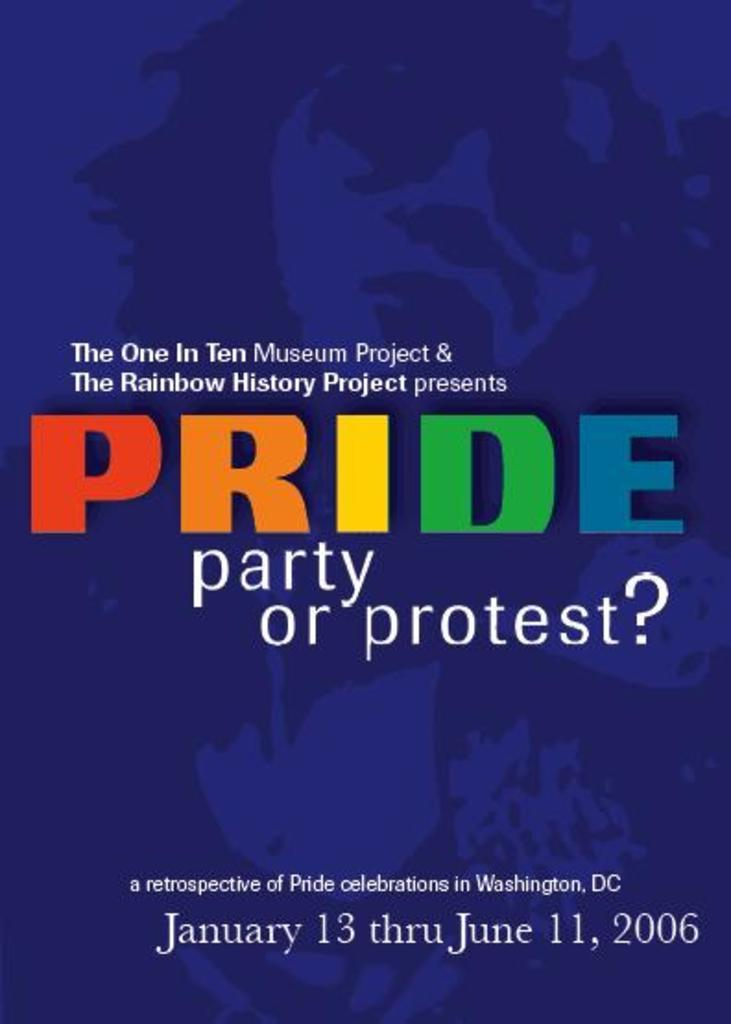<image>
Give a short and clear explanation of the subsequent image. the pride celebration event is from January to June 2006 